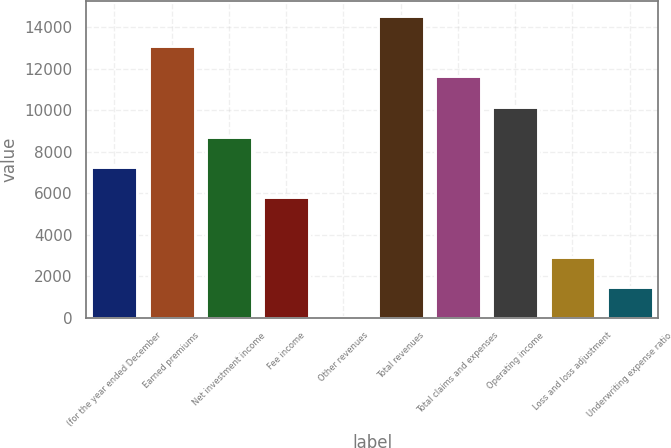Convert chart. <chart><loc_0><loc_0><loc_500><loc_500><bar_chart><fcel>(for the year ended December<fcel>Earned premiums<fcel>Net investment income<fcel>Fee income<fcel>Other revenues<fcel>Total revenues<fcel>Total claims and expenses<fcel>Operating income<fcel>Loss and loss adjustment<fcel>Underwriting expense ratio<nl><fcel>7273.5<fcel>13073.1<fcel>8723.4<fcel>5823.6<fcel>24<fcel>14523<fcel>11623.2<fcel>10173.3<fcel>2923.8<fcel>1473.9<nl></chart> 